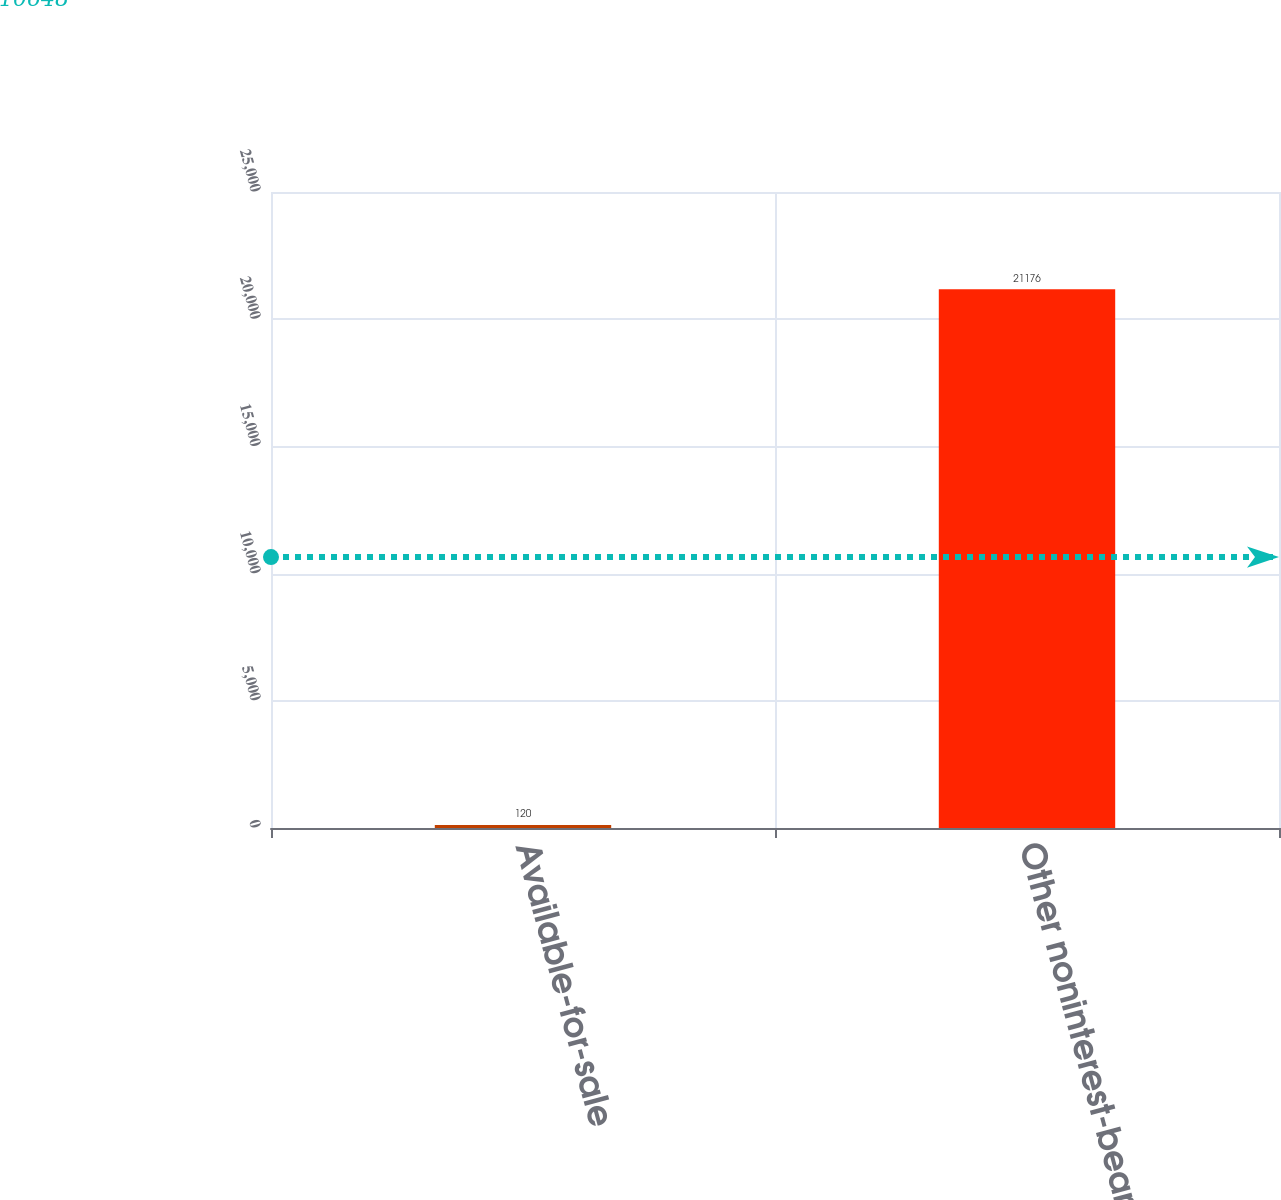<chart> <loc_0><loc_0><loc_500><loc_500><bar_chart><fcel>Available-for-sale<fcel>Other noninterest-bearing<nl><fcel>120<fcel>21176<nl></chart> 